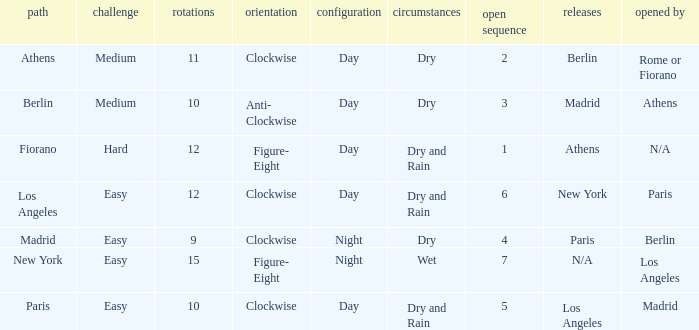What are the conditions for the athens circuit? Dry. 